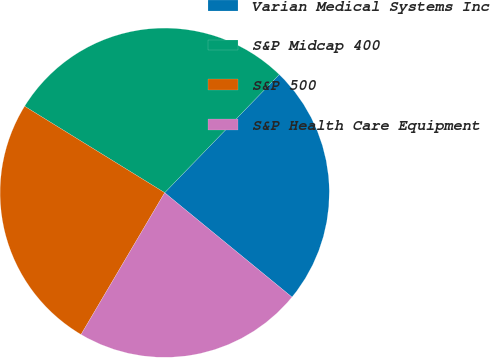Convert chart to OTSL. <chart><loc_0><loc_0><loc_500><loc_500><pie_chart><fcel>Varian Medical Systems Inc<fcel>S&P Midcap 400<fcel>S&P 500<fcel>S&P Health Care Equipment<nl><fcel>23.68%<fcel>28.45%<fcel>25.32%<fcel>22.55%<nl></chart> 